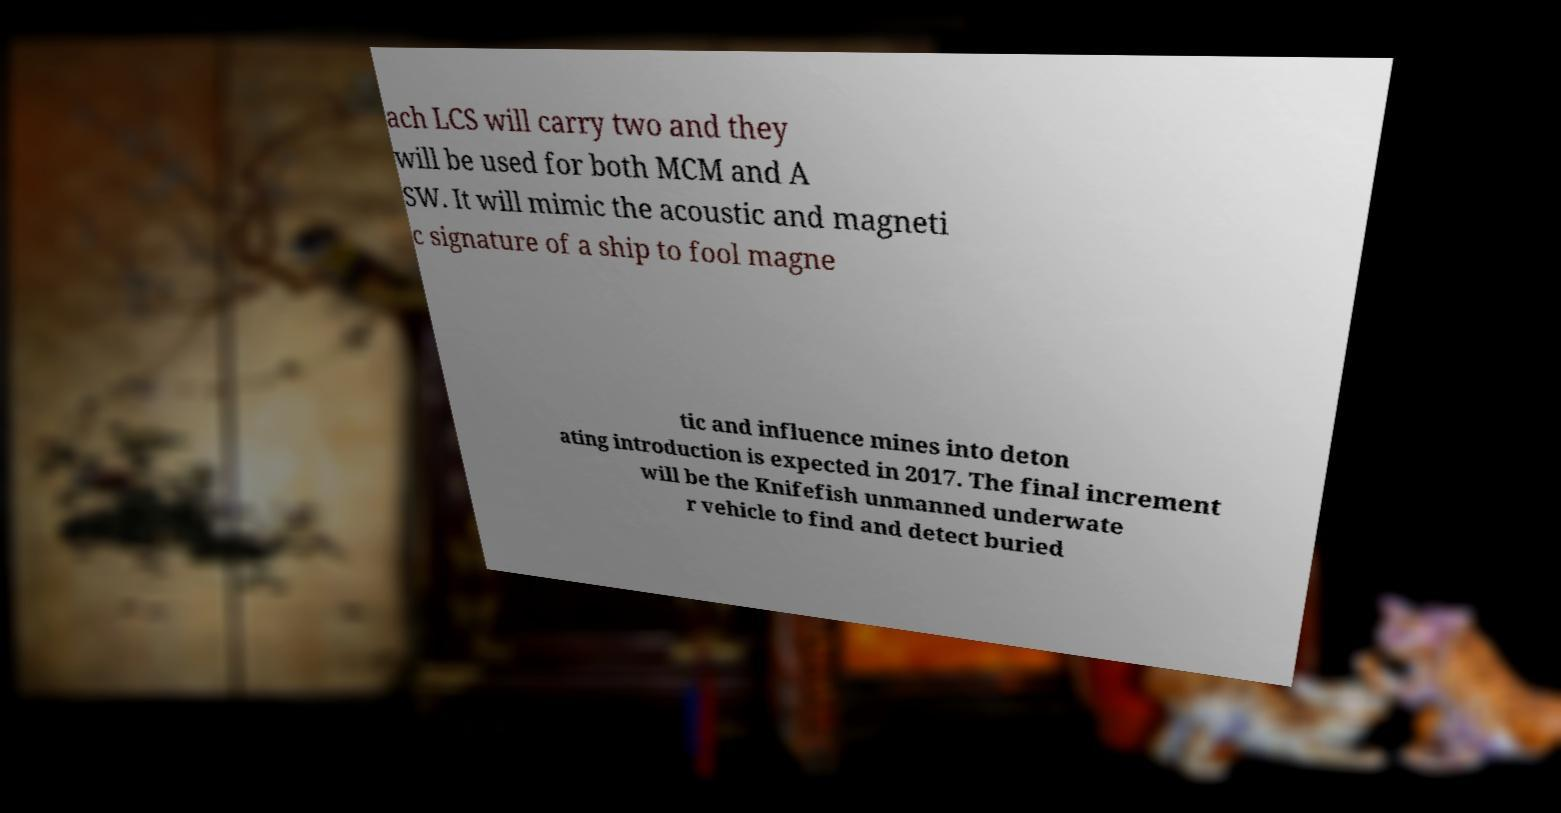What messages or text are displayed in this image? I need them in a readable, typed format. ach LCS will carry two and they will be used for both MCM and A SW. It will mimic the acoustic and magneti c signature of a ship to fool magne tic and influence mines into deton ating introduction is expected in 2017. The final increment will be the Knifefish unmanned underwate r vehicle to find and detect buried 